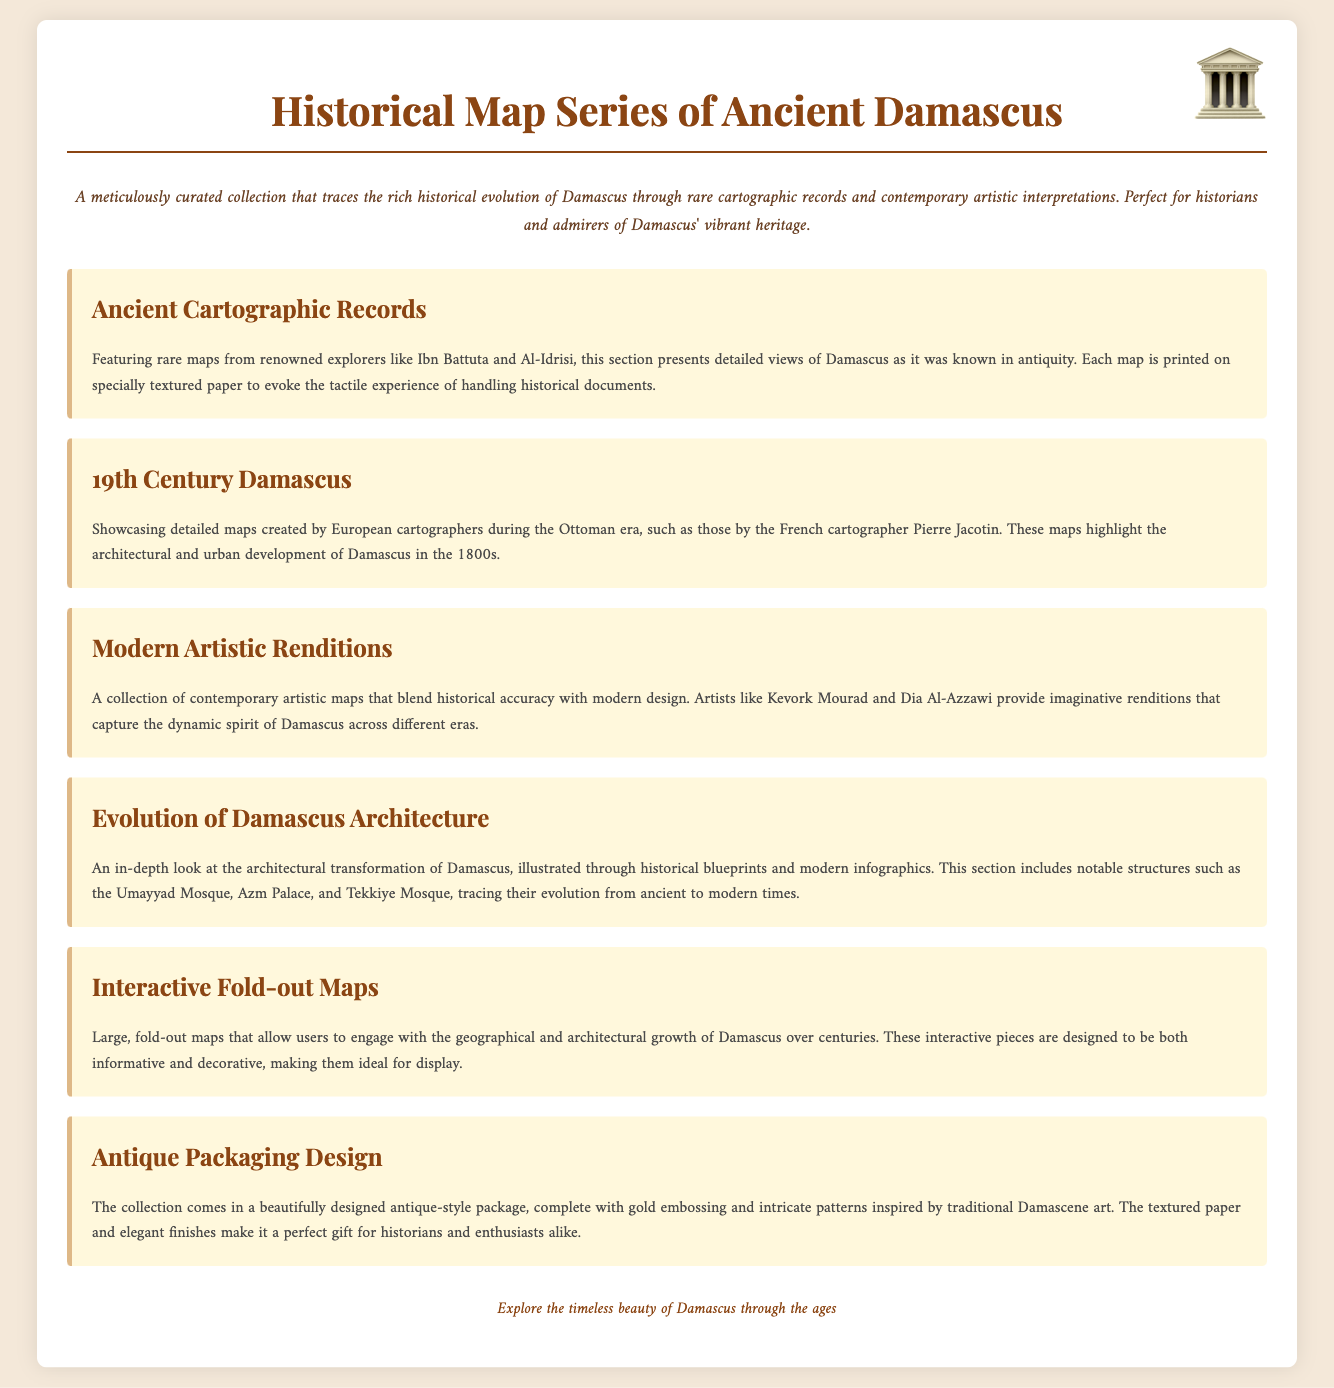What is the title of the collection? The title of the collection is prominently displayed at the top of the document.
Answer: Historical Map Series of Ancient Damascus Who are the renowned explorers featured in the ancient cartographic records? The document mentions explorers who provided rare maps of Damascus, noting their significance in the collection.
Answer: Ibn Battuta and Al-Idrisi Which century do the showcased maps by European cartographers belong to? The section concerning maps created by European cartographers refers to a specific period in history.
Answer: 19th Century What notable structure is highlighted in the architectural transformation section? The document lists significant buildings that illustrate the architectural evolution of Damascus.
Answer: Umayyad Mosque What is included in the interactive fold-out maps section? This section describes a unique feature of the collection, allowing interaction with historical geography.
Answer: Geographical and architectural growth What design style is the packaging of the collection inspired by? The document specifies the artistic inspiration behind the packaging's aesthetic.
Answer: Traditional Damascene art What type of maps do modern artistic renditions blend with historical accuracy? This part of the document discusses the fusion of different artistic perspectives toward history.
Answer: Modern design How is the description of the overall collection presented in the document? The document provides a summary of the collection, emphasizing its purpose and audience.
Answer: Meticulously curated collection 